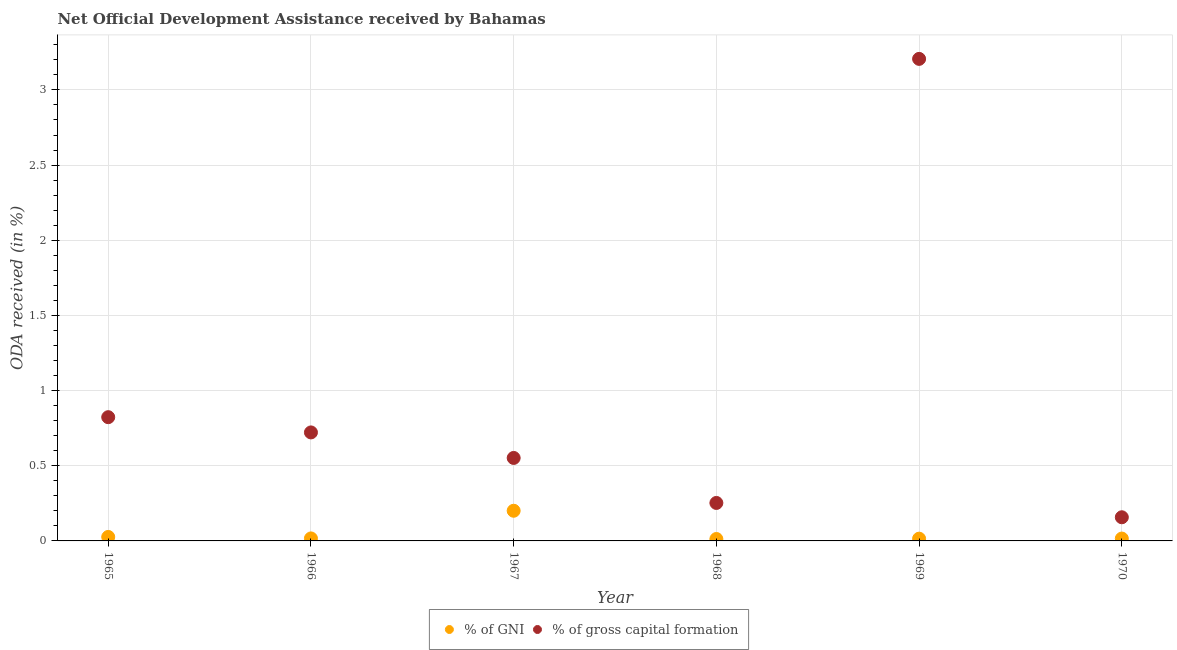Is the number of dotlines equal to the number of legend labels?
Your answer should be compact. Yes. What is the oda received as percentage of gross capital formation in 1970?
Offer a terse response. 0.16. Across all years, what is the maximum oda received as percentage of gni?
Keep it short and to the point. 0.2. Across all years, what is the minimum oda received as percentage of gross capital formation?
Provide a succinct answer. 0.16. In which year was the oda received as percentage of gni maximum?
Ensure brevity in your answer.  1967. In which year was the oda received as percentage of gni minimum?
Provide a succinct answer. 1968. What is the total oda received as percentage of gross capital formation in the graph?
Offer a terse response. 5.71. What is the difference between the oda received as percentage of gni in 1965 and that in 1968?
Your response must be concise. 0.01. What is the difference between the oda received as percentage of gross capital formation in 1966 and the oda received as percentage of gni in 1969?
Your answer should be very brief. 0.71. What is the average oda received as percentage of gni per year?
Ensure brevity in your answer.  0.05. In the year 1965, what is the difference between the oda received as percentage of gross capital formation and oda received as percentage of gni?
Keep it short and to the point. 0.8. What is the ratio of the oda received as percentage of gross capital formation in 1966 to that in 1968?
Your response must be concise. 2.86. Is the oda received as percentage of gross capital formation in 1968 less than that in 1969?
Your answer should be very brief. Yes. What is the difference between the highest and the second highest oda received as percentage of gross capital formation?
Provide a succinct answer. 2.38. What is the difference between the highest and the lowest oda received as percentage of gross capital formation?
Provide a succinct answer. 3.05. Is the oda received as percentage of gni strictly greater than the oda received as percentage of gross capital formation over the years?
Your answer should be very brief. No. Is the oda received as percentage of gni strictly less than the oda received as percentage of gross capital formation over the years?
Your answer should be very brief. Yes. Are the values on the major ticks of Y-axis written in scientific E-notation?
Offer a very short reply. No. Does the graph contain any zero values?
Offer a very short reply. No. How are the legend labels stacked?
Provide a short and direct response. Horizontal. What is the title of the graph?
Provide a succinct answer. Net Official Development Assistance received by Bahamas. Does "National Tourists" appear as one of the legend labels in the graph?
Offer a very short reply. No. What is the label or title of the X-axis?
Offer a terse response. Year. What is the label or title of the Y-axis?
Provide a succinct answer. ODA received (in %). What is the ODA received (in %) in % of GNI in 1965?
Offer a terse response. 0.03. What is the ODA received (in %) in % of gross capital formation in 1965?
Offer a terse response. 0.82. What is the ODA received (in %) of % of GNI in 1966?
Provide a short and direct response. 0.02. What is the ODA received (in %) of % of gross capital formation in 1966?
Offer a terse response. 0.72. What is the ODA received (in %) of % of GNI in 1967?
Ensure brevity in your answer.  0.2. What is the ODA received (in %) of % of gross capital formation in 1967?
Your answer should be very brief. 0.55. What is the ODA received (in %) of % of GNI in 1968?
Provide a short and direct response. 0.01. What is the ODA received (in %) in % of gross capital formation in 1968?
Your answer should be very brief. 0.25. What is the ODA received (in %) of % of GNI in 1969?
Your answer should be very brief. 0.02. What is the ODA received (in %) of % of gross capital formation in 1969?
Your response must be concise. 3.21. What is the ODA received (in %) in % of GNI in 1970?
Provide a succinct answer. 0.02. What is the ODA received (in %) in % of gross capital formation in 1970?
Your response must be concise. 0.16. Across all years, what is the maximum ODA received (in %) in % of GNI?
Your response must be concise. 0.2. Across all years, what is the maximum ODA received (in %) in % of gross capital formation?
Your response must be concise. 3.21. Across all years, what is the minimum ODA received (in %) of % of GNI?
Provide a succinct answer. 0.01. Across all years, what is the minimum ODA received (in %) of % of gross capital formation?
Make the answer very short. 0.16. What is the total ODA received (in %) in % of GNI in the graph?
Your answer should be compact. 0.29. What is the total ODA received (in %) of % of gross capital formation in the graph?
Ensure brevity in your answer.  5.71. What is the difference between the ODA received (in %) in % of GNI in 1965 and that in 1966?
Provide a succinct answer. 0.01. What is the difference between the ODA received (in %) of % of gross capital formation in 1965 and that in 1966?
Offer a terse response. 0.1. What is the difference between the ODA received (in %) of % of GNI in 1965 and that in 1967?
Provide a short and direct response. -0.17. What is the difference between the ODA received (in %) of % of gross capital formation in 1965 and that in 1967?
Make the answer very short. 0.27. What is the difference between the ODA received (in %) of % of GNI in 1965 and that in 1968?
Offer a terse response. 0.01. What is the difference between the ODA received (in %) in % of gross capital formation in 1965 and that in 1968?
Provide a succinct answer. 0.57. What is the difference between the ODA received (in %) of % of GNI in 1965 and that in 1969?
Your answer should be very brief. 0.01. What is the difference between the ODA received (in %) in % of gross capital formation in 1965 and that in 1969?
Provide a succinct answer. -2.38. What is the difference between the ODA received (in %) in % of GNI in 1965 and that in 1970?
Make the answer very short. 0.01. What is the difference between the ODA received (in %) of % of gross capital formation in 1965 and that in 1970?
Make the answer very short. 0.67. What is the difference between the ODA received (in %) in % of GNI in 1966 and that in 1967?
Offer a terse response. -0.18. What is the difference between the ODA received (in %) in % of gross capital formation in 1966 and that in 1967?
Make the answer very short. 0.17. What is the difference between the ODA received (in %) of % of GNI in 1966 and that in 1968?
Make the answer very short. 0. What is the difference between the ODA received (in %) in % of gross capital formation in 1966 and that in 1968?
Your answer should be very brief. 0.47. What is the difference between the ODA received (in %) of % of GNI in 1966 and that in 1969?
Provide a short and direct response. 0. What is the difference between the ODA received (in %) in % of gross capital formation in 1966 and that in 1969?
Your answer should be very brief. -2.48. What is the difference between the ODA received (in %) in % of GNI in 1966 and that in 1970?
Make the answer very short. 0. What is the difference between the ODA received (in %) of % of gross capital formation in 1966 and that in 1970?
Keep it short and to the point. 0.56. What is the difference between the ODA received (in %) in % of GNI in 1967 and that in 1968?
Your response must be concise. 0.19. What is the difference between the ODA received (in %) in % of gross capital formation in 1967 and that in 1968?
Your answer should be compact. 0.3. What is the difference between the ODA received (in %) in % of GNI in 1967 and that in 1969?
Offer a very short reply. 0.19. What is the difference between the ODA received (in %) in % of gross capital formation in 1967 and that in 1969?
Your answer should be compact. -2.65. What is the difference between the ODA received (in %) of % of GNI in 1967 and that in 1970?
Your answer should be compact. 0.18. What is the difference between the ODA received (in %) in % of gross capital formation in 1967 and that in 1970?
Ensure brevity in your answer.  0.39. What is the difference between the ODA received (in %) in % of GNI in 1968 and that in 1969?
Offer a terse response. -0. What is the difference between the ODA received (in %) of % of gross capital formation in 1968 and that in 1969?
Ensure brevity in your answer.  -2.95. What is the difference between the ODA received (in %) of % of GNI in 1968 and that in 1970?
Make the answer very short. -0. What is the difference between the ODA received (in %) in % of gross capital formation in 1968 and that in 1970?
Provide a succinct answer. 0.1. What is the difference between the ODA received (in %) of % of GNI in 1969 and that in 1970?
Give a very brief answer. -0. What is the difference between the ODA received (in %) of % of gross capital formation in 1969 and that in 1970?
Provide a short and direct response. 3.05. What is the difference between the ODA received (in %) of % of GNI in 1965 and the ODA received (in %) of % of gross capital formation in 1966?
Ensure brevity in your answer.  -0.7. What is the difference between the ODA received (in %) in % of GNI in 1965 and the ODA received (in %) in % of gross capital formation in 1967?
Give a very brief answer. -0.53. What is the difference between the ODA received (in %) in % of GNI in 1965 and the ODA received (in %) in % of gross capital formation in 1968?
Your answer should be compact. -0.23. What is the difference between the ODA received (in %) in % of GNI in 1965 and the ODA received (in %) in % of gross capital formation in 1969?
Your answer should be compact. -3.18. What is the difference between the ODA received (in %) in % of GNI in 1965 and the ODA received (in %) in % of gross capital formation in 1970?
Ensure brevity in your answer.  -0.13. What is the difference between the ODA received (in %) in % of GNI in 1966 and the ODA received (in %) in % of gross capital formation in 1967?
Make the answer very short. -0.54. What is the difference between the ODA received (in %) of % of GNI in 1966 and the ODA received (in %) of % of gross capital formation in 1968?
Give a very brief answer. -0.24. What is the difference between the ODA received (in %) of % of GNI in 1966 and the ODA received (in %) of % of gross capital formation in 1969?
Your answer should be compact. -3.19. What is the difference between the ODA received (in %) in % of GNI in 1966 and the ODA received (in %) in % of gross capital formation in 1970?
Make the answer very short. -0.14. What is the difference between the ODA received (in %) of % of GNI in 1967 and the ODA received (in %) of % of gross capital formation in 1968?
Your response must be concise. -0.05. What is the difference between the ODA received (in %) in % of GNI in 1967 and the ODA received (in %) in % of gross capital formation in 1969?
Provide a succinct answer. -3.01. What is the difference between the ODA received (in %) of % of GNI in 1967 and the ODA received (in %) of % of gross capital formation in 1970?
Your answer should be very brief. 0.04. What is the difference between the ODA received (in %) of % of GNI in 1968 and the ODA received (in %) of % of gross capital formation in 1969?
Make the answer very short. -3.19. What is the difference between the ODA received (in %) of % of GNI in 1968 and the ODA received (in %) of % of gross capital formation in 1970?
Ensure brevity in your answer.  -0.14. What is the difference between the ODA received (in %) of % of GNI in 1969 and the ODA received (in %) of % of gross capital formation in 1970?
Give a very brief answer. -0.14. What is the average ODA received (in %) of % of GNI per year?
Your answer should be compact. 0.05. What is the average ODA received (in %) in % of gross capital formation per year?
Your answer should be very brief. 0.95. In the year 1965, what is the difference between the ODA received (in %) of % of GNI and ODA received (in %) of % of gross capital formation?
Make the answer very short. -0.8. In the year 1966, what is the difference between the ODA received (in %) in % of GNI and ODA received (in %) in % of gross capital formation?
Make the answer very short. -0.7. In the year 1967, what is the difference between the ODA received (in %) of % of GNI and ODA received (in %) of % of gross capital formation?
Your answer should be very brief. -0.35. In the year 1968, what is the difference between the ODA received (in %) in % of GNI and ODA received (in %) in % of gross capital formation?
Make the answer very short. -0.24. In the year 1969, what is the difference between the ODA received (in %) of % of GNI and ODA received (in %) of % of gross capital formation?
Give a very brief answer. -3.19. In the year 1970, what is the difference between the ODA received (in %) in % of GNI and ODA received (in %) in % of gross capital formation?
Ensure brevity in your answer.  -0.14. What is the ratio of the ODA received (in %) of % of GNI in 1965 to that in 1966?
Give a very brief answer. 1.58. What is the ratio of the ODA received (in %) of % of gross capital formation in 1965 to that in 1966?
Offer a terse response. 1.14. What is the ratio of the ODA received (in %) in % of GNI in 1965 to that in 1967?
Ensure brevity in your answer.  0.13. What is the ratio of the ODA received (in %) of % of gross capital formation in 1965 to that in 1967?
Offer a very short reply. 1.49. What is the ratio of the ODA received (in %) in % of GNI in 1965 to that in 1968?
Ensure brevity in your answer.  2.07. What is the ratio of the ODA received (in %) in % of gross capital formation in 1965 to that in 1968?
Give a very brief answer. 3.26. What is the ratio of the ODA received (in %) in % of GNI in 1965 to that in 1969?
Give a very brief answer. 1.76. What is the ratio of the ODA received (in %) of % of gross capital formation in 1965 to that in 1969?
Give a very brief answer. 0.26. What is the ratio of the ODA received (in %) of % of GNI in 1965 to that in 1970?
Ensure brevity in your answer.  1.68. What is the ratio of the ODA received (in %) in % of gross capital formation in 1965 to that in 1970?
Make the answer very short. 5.23. What is the ratio of the ODA received (in %) of % of GNI in 1966 to that in 1967?
Your answer should be very brief. 0.08. What is the ratio of the ODA received (in %) in % of gross capital formation in 1966 to that in 1967?
Offer a terse response. 1.31. What is the ratio of the ODA received (in %) in % of GNI in 1966 to that in 1968?
Give a very brief answer. 1.31. What is the ratio of the ODA received (in %) of % of gross capital formation in 1966 to that in 1968?
Offer a very short reply. 2.86. What is the ratio of the ODA received (in %) of % of GNI in 1966 to that in 1969?
Ensure brevity in your answer.  1.11. What is the ratio of the ODA received (in %) in % of gross capital formation in 1966 to that in 1969?
Your answer should be very brief. 0.23. What is the ratio of the ODA received (in %) of % of GNI in 1966 to that in 1970?
Ensure brevity in your answer.  1.06. What is the ratio of the ODA received (in %) of % of gross capital formation in 1966 to that in 1970?
Offer a very short reply. 4.59. What is the ratio of the ODA received (in %) of % of GNI in 1967 to that in 1968?
Ensure brevity in your answer.  15.73. What is the ratio of the ODA received (in %) of % of gross capital formation in 1967 to that in 1968?
Your answer should be very brief. 2.18. What is the ratio of the ODA received (in %) of % of GNI in 1967 to that in 1969?
Provide a short and direct response. 13.34. What is the ratio of the ODA received (in %) in % of gross capital formation in 1967 to that in 1969?
Your answer should be compact. 0.17. What is the ratio of the ODA received (in %) in % of GNI in 1967 to that in 1970?
Ensure brevity in your answer.  12.78. What is the ratio of the ODA received (in %) of % of gross capital formation in 1967 to that in 1970?
Offer a terse response. 3.51. What is the ratio of the ODA received (in %) of % of GNI in 1968 to that in 1969?
Ensure brevity in your answer.  0.85. What is the ratio of the ODA received (in %) in % of gross capital formation in 1968 to that in 1969?
Your answer should be very brief. 0.08. What is the ratio of the ODA received (in %) in % of GNI in 1968 to that in 1970?
Keep it short and to the point. 0.81. What is the ratio of the ODA received (in %) in % of gross capital formation in 1968 to that in 1970?
Ensure brevity in your answer.  1.61. What is the ratio of the ODA received (in %) of % of GNI in 1969 to that in 1970?
Provide a short and direct response. 0.96. What is the ratio of the ODA received (in %) in % of gross capital formation in 1969 to that in 1970?
Your response must be concise. 20.38. What is the difference between the highest and the second highest ODA received (in %) in % of GNI?
Provide a short and direct response. 0.17. What is the difference between the highest and the second highest ODA received (in %) in % of gross capital formation?
Offer a terse response. 2.38. What is the difference between the highest and the lowest ODA received (in %) in % of GNI?
Your answer should be compact. 0.19. What is the difference between the highest and the lowest ODA received (in %) of % of gross capital formation?
Give a very brief answer. 3.05. 